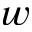<formula> <loc_0><loc_0><loc_500><loc_500>w</formula> 